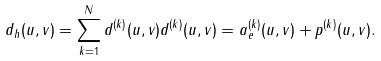<formula> <loc_0><loc_0><loc_500><loc_500>d _ { h } ( u , v ) = \sum _ { k = 1 } ^ { N } d ^ { ( k ) } ( u , v ) d ^ { ( k ) } ( u , v ) = a _ { e } ^ { ( k ) } ( u , v ) + p ^ { ( k ) } ( u , v ) .</formula> 